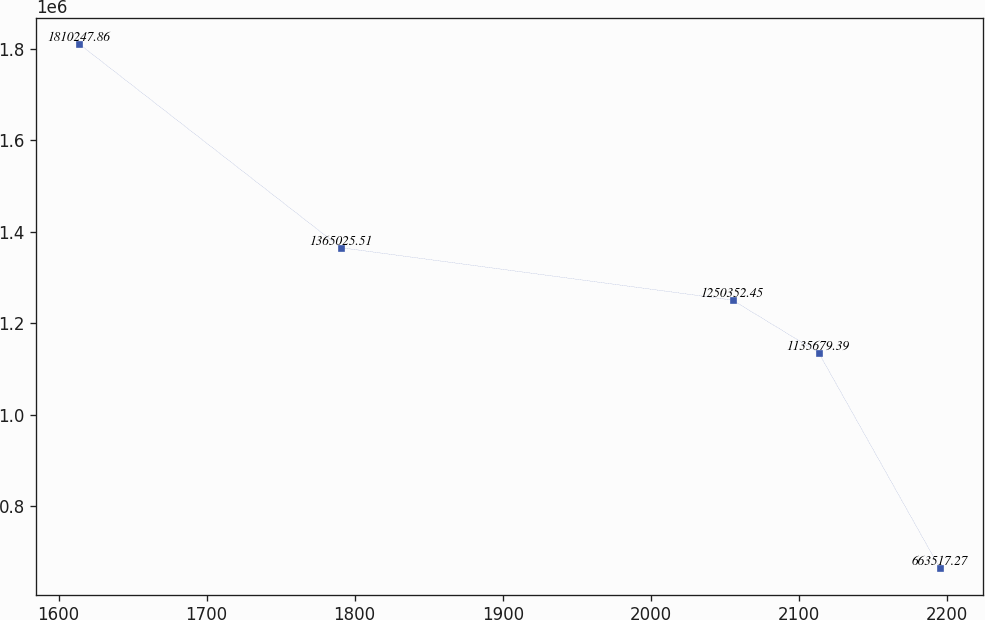<chart> <loc_0><loc_0><loc_500><loc_500><line_chart><ecel><fcel>Unnamed: 1<nl><fcel>1614.1<fcel>1.81025e+06<nl><fcel>1790.76<fcel>1.36503e+06<nl><fcel>2055.22<fcel>1.25035e+06<nl><fcel>2113.35<fcel>1.13568e+06<nl><fcel>2195.37<fcel>663517<nl></chart> 